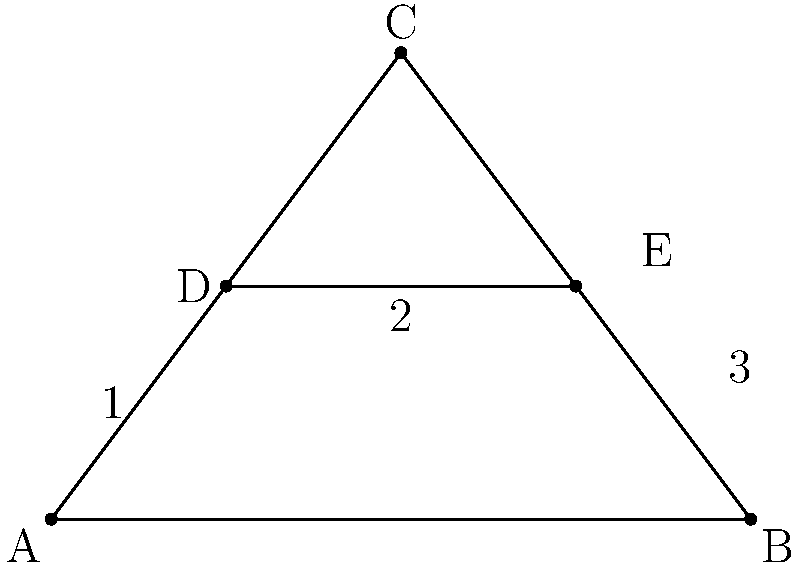In a movie theater, the seating arrangement forms a triangular shape. The diagram above represents this arrangement, where $\triangle ABC$ is the overall seating area, and line segment $DE$ represents a row of seats. If $\overline{AD} \cong \overline{DE} \cong \overline{EB}$, prove that $\triangle ACD \cong \triangle BCE$. Let's approach this step-by-step:

1) Given: $\overline{AD} \cong \overline{DE} \cong \overline{EB}$

2) In $\triangle ABC$, $DE$ is parallel to $AB$ (as it represents a row of seats). This means that $\triangle ACD$ and $\triangle BCE$ are similar by the similarity of triangles theorem.

3) Since $\overline{AD} \cong \overline{DE} \cong \overline{EB}$, we can conclude that $D$ and $E$ are midpoints of $\overline{AC}$ and $\overline{BC}$ respectively.

4) In $\triangle ABC$:
   $\overline{AC} = 2\overline{AD}$ (since $D$ is the midpoint of $\overline{AC}$)
   $\overline{BC} = 2\overline{BE}$ (since $E$ is the midpoint of $\overline{BC}$)

5) But $\overline{AD} \cong \overline{EB}$, so $\overline{AC} \cong \overline{BC}$

6) This means that $\triangle ABC$ is isosceles, with $\overline{AC} \cong \overline{BC}$

7) In an isosceles triangle, the angles opposite the equal sides are equal. So, $\angle CAB \cong \angle CBA$

8) Now, in $\triangle ACD$ and $\triangle BCE$:
   - $\overline{AC} \cong \overline{BC}$ (proved in step 6)
   - $\angle CAD \cong \angle CBE$ (alternate angles, as $DE$ is parallel to $AB$)
   - $\angle ACD \cong \angle BCE$ (proved in step 7)

9) By the ASA (Angle-Side-Angle) congruence criterion, $\triangle ACD \cong \triangle BCE$

Thus, we have proved that $\triangle ACD \cong \triangle BCE$.
Answer: $\triangle ACD \cong \triangle BCE$ by ASA 